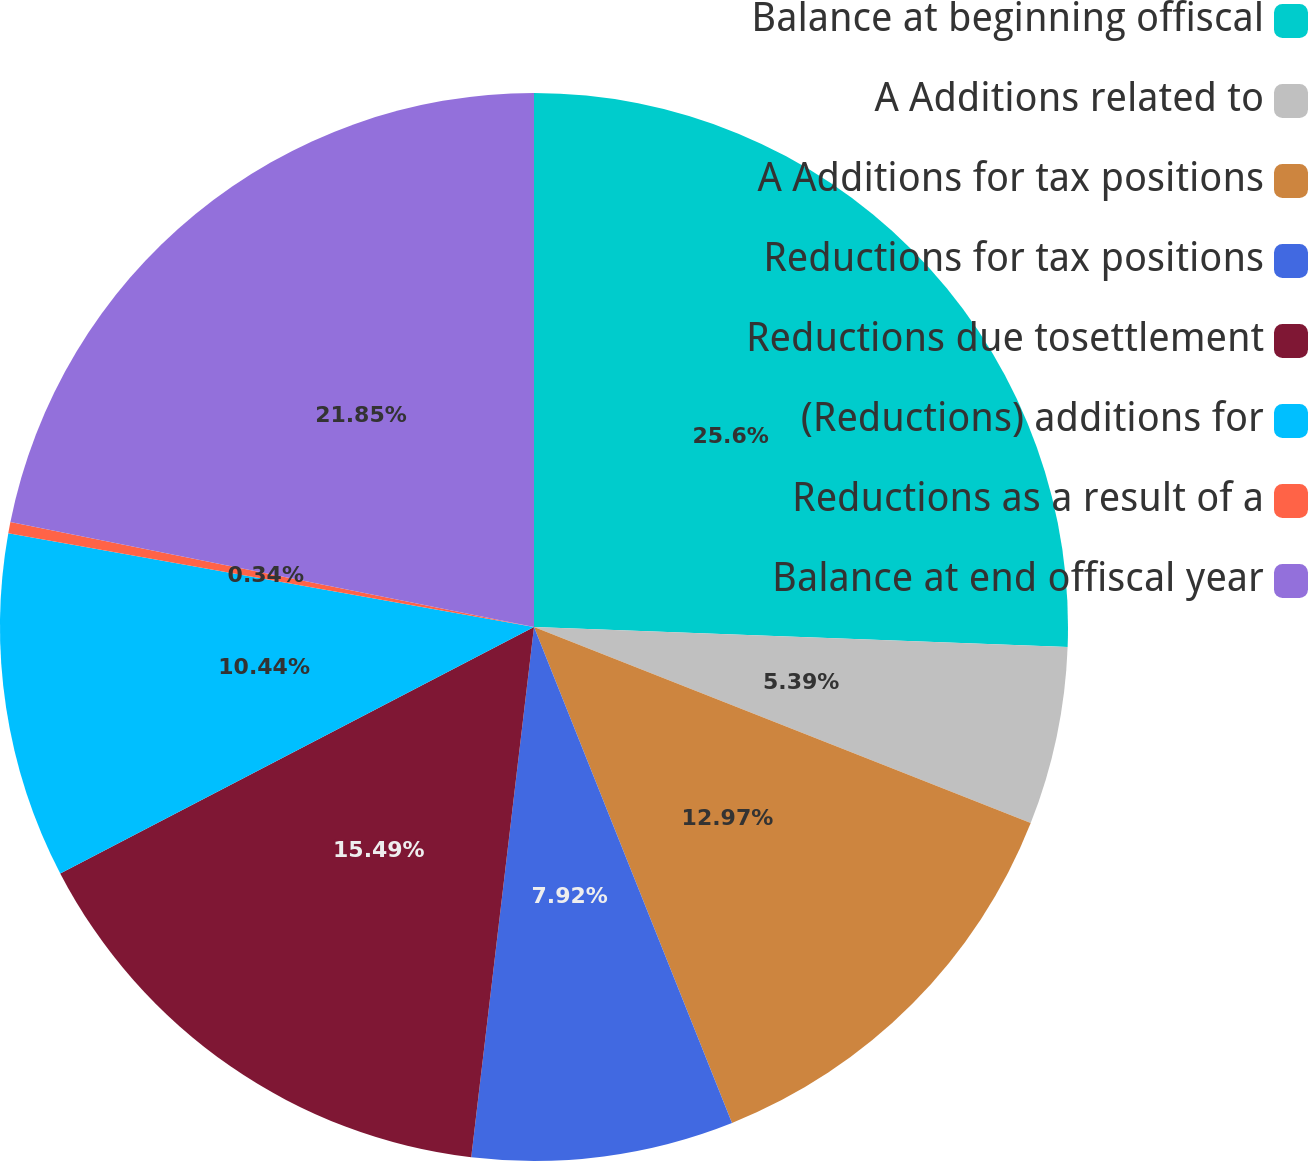<chart> <loc_0><loc_0><loc_500><loc_500><pie_chart><fcel>Balance at beginning offiscal<fcel>A Additions related to<fcel>A Additions for tax positions<fcel>Reductions for tax positions<fcel>Reductions due tosettlement<fcel>(Reductions) additions for<fcel>Reductions as a result of a<fcel>Balance at end offiscal year<nl><fcel>25.59%<fcel>5.39%<fcel>12.97%<fcel>7.92%<fcel>15.49%<fcel>10.44%<fcel>0.34%<fcel>21.85%<nl></chart> 